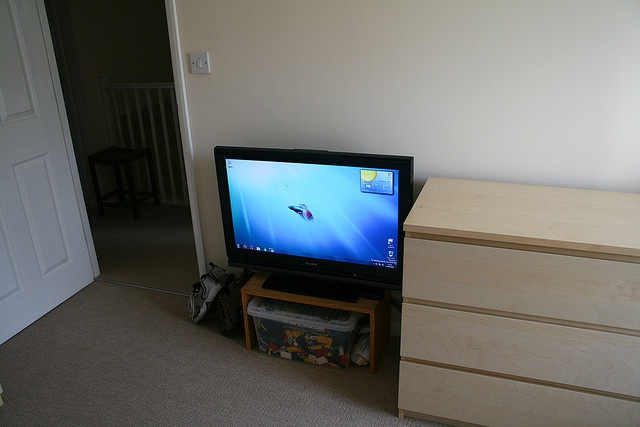Describe the objects in this image and their specific colors. I can see a tv in gray, black, and lightblue tones in this image. 